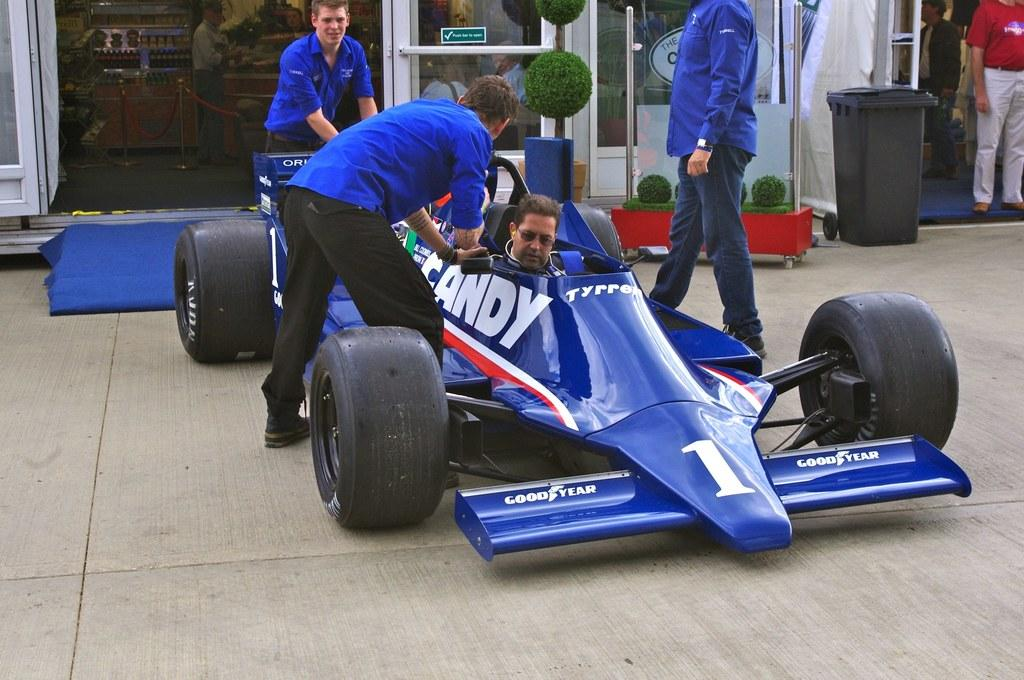What is the person in the image doing? There is a person sitting in a sports car in the image. Are there any other people in the image? Yes, there are three men standing near the car. What can be seen in the background of the image? There are plants, shops, and people visible in the background. What type of screw is being used to hold the idea together in the image? There is no mention of a screw, idea, or any related activity in the image. 